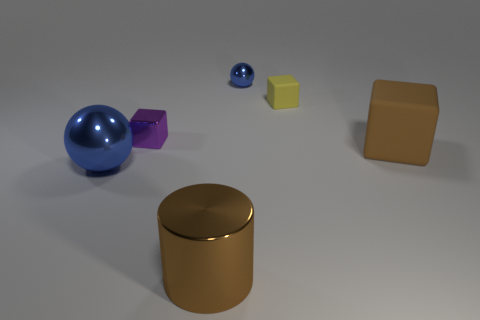Subtract all blue balls. How many were subtracted if there are1blue balls left? 1 Subtract all purple metallic cubes. How many cubes are left? 2 Subtract 2 blocks. How many blocks are left? 1 Add 1 tiny rubber objects. How many objects exist? 7 Subtract all brown cubes. How many cubes are left? 2 Subtract all cylinders. How many objects are left? 5 Subtract all cyan cylinders. How many yellow blocks are left? 1 Subtract all small cyan cylinders. Subtract all tiny blue objects. How many objects are left? 5 Add 3 large brown blocks. How many large brown blocks are left? 4 Add 2 brown blocks. How many brown blocks exist? 3 